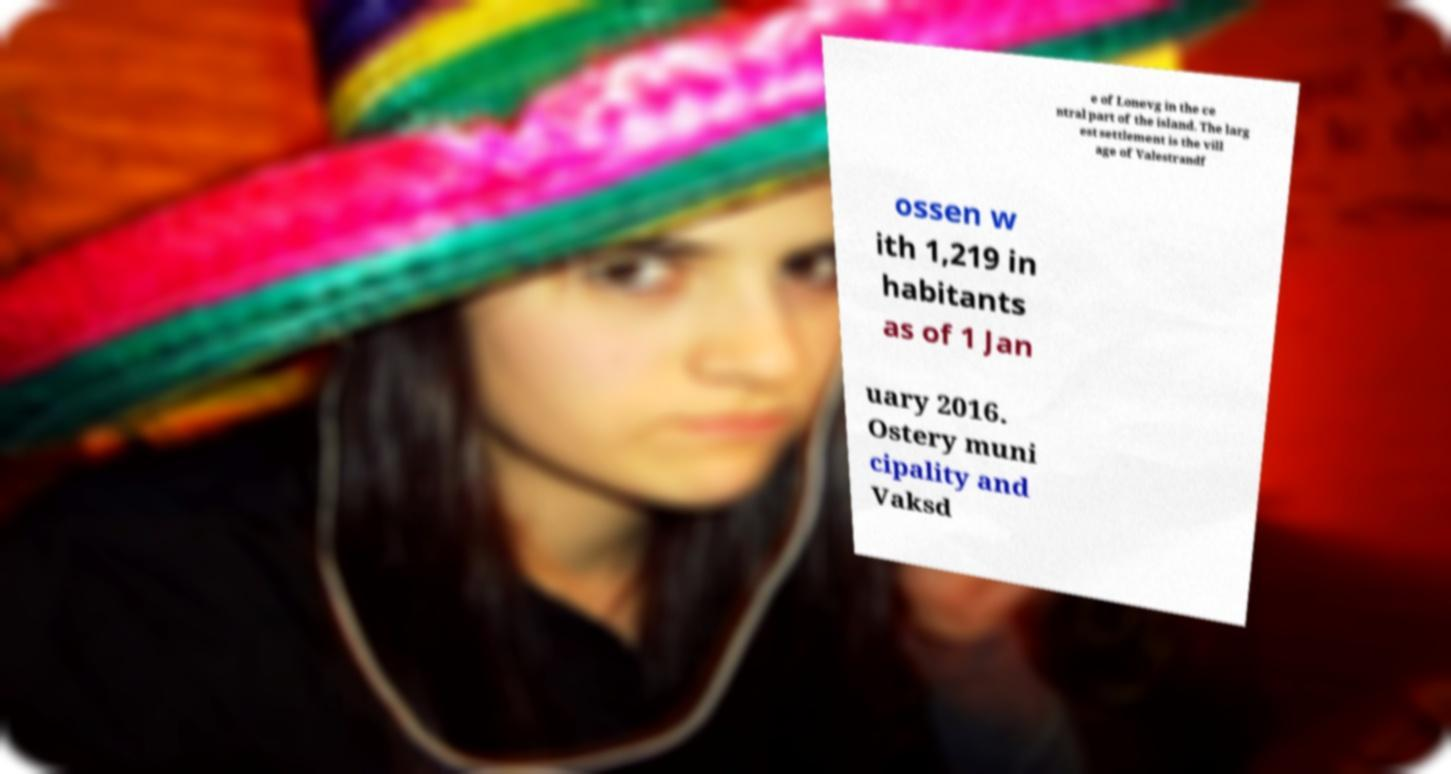Could you extract and type out the text from this image? e of Lonevg in the ce ntral part of the island. The larg est settlement is the vill age of Valestrandf ossen w ith 1,219 in habitants as of 1 Jan uary 2016. Ostery muni cipality and Vaksd 